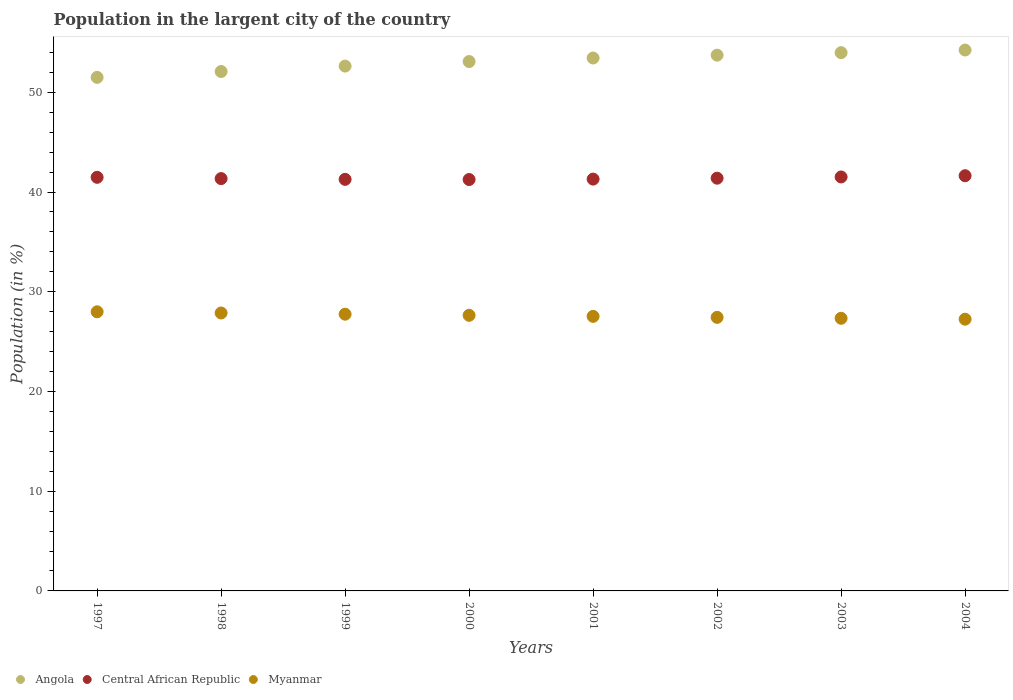Is the number of dotlines equal to the number of legend labels?
Provide a short and direct response. Yes. What is the percentage of population in the largent city in Central African Republic in 2001?
Provide a short and direct response. 41.29. Across all years, what is the maximum percentage of population in the largent city in Central African Republic?
Your answer should be compact. 41.63. Across all years, what is the minimum percentage of population in the largent city in Angola?
Your answer should be very brief. 51.49. In which year was the percentage of population in the largent city in Angola maximum?
Keep it short and to the point. 2004. What is the total percentage of population in the largent city in Central African Republic in the graph?
Your response must be concise. 331.16. What is the difference between the percentage of population in the largent city in Angola in 2000 and that in 2004?
Your answer should be very brief. -1.15. What is the difference between the percentage of population in the largent city in Angola in 2002 and the percentage of population in the largent city in Central African Republic in 2003?
Your answer should be compact. 12.21. What is the average percentage of population in the largent city in Central African Republic per year?
Keep it short and to the point. 41.39. In the year 1999, what is the difference between the percentage of population in the largent city in Myanmar and percentage of population in the largent city in Central African Republic?
Offer a very short reply. -13.52. In how many years, is the percentage of population in the largent city in Angola greater than 34 %?
Offer a terse response. 8. What is the ratio of the percentage of population in the largent city in Central African Republic in 1999 to that in 2000?
Keep it short and to the point. 1. Is the difference between the percentage of population in the largent city in Myanmar in 2000 and 2003 greater than the difference between the percentage of population in the largent city in Central African Republic in 2000 and 2003?
Offer a very short reply. Yes. What is the difference between the highest and the second highest percentage of population in the largent city in Angola?
Provide a succinct answer. 0.26. What is the difference between the highest and the lowest percentage of population in the largent city in Angola?
Your answer should be very brief. 2.74. In how many years, is the percentage of population in the largent city in Myanmar greater than the average percentage of population in the largent city in Myanmar taken over all years?
Provide a succinct answer. 4. Does the percentage of population in the largent city in Angola monotonically increase over the years?
Your response must be concise. Yes. How many years are there in the graph?
Give a very brief answer. 8. What is the difference between two consecutive major ticks on the Y-axis?
Your answer should be compact. 10. Does the graph contain any zero values?
Your answer should be compact. No. How are the legend labels stacked?
Give a very brief answer. Horizontal. What is the title of the graph?
Offer a very short reply. Population in the largent city of the country. What is the label or title of the Y-axis?
Keep it short and to the point. Population (in %). What is the Population (in %) in Angola in 1997?
Provide a short and direct response. 51.49. What is the Population (in %) in Central African Republic in 1997?
Give a very brief answer. 41.47. What is the Population (in %) in Myanmar in 1997?
Make the answer very short. 27.99. What is the Population (in %) in Angola in 1998?
Provide a short and direct response. 52.08. What is the Population (in %) of Central African Republic in 1998?
Offer a very short reply. 41.35. What is the Population (in %) of Myanmar in 1998?
Provide a succinct answer. 27.87. What is the Population (in %) of Angola in 1999?
Ensure brevity in your answer.  52.63. What is the Population (in %) in Central African Republic in 1999?
Offer a very short reply. 41.27. What is the Population (in %) in Myanmar in 1999?
Give a very brief answer. 27.75. What is the Population (in %) of Angola in 2000?
Your answer should be compact. 53.08. What is the Population (in %) of Central African Republic in 2000?
Offer a very short reply. 41.25. What is the Population (in %) of Myanmar in 2000?
Provide a short and direct response. 27.64. What is the Population (in %) in Angola in 2001?
Your response must be concise. 53.44. What is the Population (in %) in Central African Republic in 2001?
Your answer should be compact. 41.29. What is the Population (in %) of Myanmar in 2001?
Your answer should be compact. 27.53. What is the Population (in %) in Angola in 2002?
Ensure brevity in your answer.  53.72. What is the Population (in %) of Central African Republic in 2002?
Offer a terse response. 41.39. What is the Population (in %) of Myanmar in 2002?
Make the answer very short. 27.43. What is the Population (in %) of Angola in 2003?
Provide a short and direct response. 53.97. What is the Population (in %) of Central African Republic in 2003?
Offer a very short reply. 41.51. What is the Population (in %) in Myanmar in 2003?
Make the answer very short. 27.34. What is the Population (in %) of Angola in 2004?
Your response must be concise. 54.24. What is the Population (in %) in Central African Republic in 2004?
Your answer should be compact. 41.63. What is the Population (in %) in Myanmar in 2004?
Offer a terse response. 27.25. Across all years, what is the maximum Population (in %) in Angola?
Give a very brief answer. 54.24. Across all years, what is the maximum Population (in %) in Central African Republic?
Ensure brevity in your answer.  41.63. Across all years, what is the maximum Population (in %) in Myanmar?
Ensure brevity in your answer.  27.99. Across all years, what is the minimum Population (in %) of Angola?
Keep it short and to the point. 51.49. Across all years, what is the minimum Population (in %) of Central African Republic?
Your answer should be compact. 41.25. Across all years, what is the minimum Population (in %) of Myanmar?
Offer a very short reply. 27.25. What is the total Population (in %) in Angola in the graph?
Offer a very short reply. 424.65. What is the total Population (in %) of Central African Republic in the graph?
Give a very brief answer. 331.16. What is the total Population (in %) of Myanmar in the graph?
Offer a very short reply. 220.79. What is the difference between the Population (in %) of Angola in 1997 and that in 1998?
Ensure brevity in your answer.  -0.59. What is the difference between the Population (in %) in Central African Republic in 1997 and that in 1998?
Ensure brevity in your answer.  0.13. What is the difference between the Population (in %) of Myanmar in 1997 and that in 1998?
Your response must be concise. 0.12. What is the difference between the Population (in %) in Angola in 1997 and that in 1999?
Your answer should be very brief. -1.13. What is the difference between the Population (in %) in Central African Republic in 1997 and that in 1999?
Your answer should be very brief. 0.2. What is the difference between the Population (in %) of Myanmar in 1997 and that in 1999?
Your answer should be very brief. 0.24. What is the difference between the Population (in %) in Angola in 1997 and that in 2000?
Your answer should be compact. -1.59. What is the difference between the Population (in %) of Central African Republic in 1997 and that in 2000?
Keep it short and to the point. 0.22. What is the difference between the Population (in %) of Myanmar in 1997 and that in 2000?
Offer a terse response. 0.35. What is the difference between the Population (in %) of Angola in 1997 and that in 2001?
Your response must be concise. -1.94. What is the difference between the Population (in %) in Central African Republic in 1997 and that in 2001?
Provide a succinct answer. 0.18. What is the difference between the Population (in %) in Myanmar in 1997 and that in 2001?
Your answer should be compact. 0.46. What is the difference between the Population (in %) in Angola in 1997 and that in 2002?
Your response must be concise. -2.23. What is the difference between the Population (in %) of Central African Republic in 1997 and that in 2002?
Offer a very short reply. 0.09. What is the difference between the Population (in %) of Myanmar in 1997 and that in 2002?
Make the answer very short. 0.56. What is the difference between the Population (in %) of Angola in 1997 and that in 2003?
Give a very brief answer. -2.48. What is the difference between the Population (in %) of Central African Republic in 1997 and that in 2003?
Provide a short and direct response. -0.04. What is the difference between the Population (in %) in Myanmar in 1997 and that in 2003?
Your answer should be very brief. 0.65. What is the difference between the Population (in %) in Angola in 1997 and that in 2004?
Your answer should be very brief. -2.74. What is the difference between the Population (in %) in Central African Republic in 1997 and that in 2004?
Keep it short and to the point. -0.16. What is the difference between the Population (in %) of Myanmar in 1997 and that in 2004?
Provide a succinct answer. 0.74. What is the difference between the Population (in %) of Angola in 1998 and that in 1999?
Ensure brevity in your answer.  -0.54. What is the difference between the Population (in %) in Central African Republic in 1998 and that in 1999?
Keep it short and to the point. 0.08. What is the difference between the Population (in %) of Myanmar in 1998 and that in 1999?
Make the answer very short. 0.12. What is the difference between the Population (in %) of Angola in 1998 and that in 2000?
Offer a very short reply. -1. What is the difference between the Population (in %) in Central African Republic in 1998 and that in 2000?
Provide a short and direct response. 0.09. What is the difference between the Population (in %) in Myanmar in 1998 and that in 2000?
Keep it short and to the point. 0.23. What is the difference between the Population (in %) of Angola in 1998 and that in 2001?
Ensure brevity in your answer.  -1.35. What is the difference between the Population (in %) of Central African Republic in 1998 and that in 2001?
Ensure brevity in your answer.  0.05. What is the difference between the Population (in %) in Myanmar in 1998 and that in 2001?
Make the answer very short. 0.34. What is the difference between the Population (in %) in Angola in 1998 and that in 2002?
Your answer should be compact. -1.64. What is the difference between the Population (in %) of Central African Republic in 1998 and that in 2002?
Offer a very short reply. -0.04. What is the difference between the Population (in %) of Myanmar in 1998 and that in 2002?
Offer a very short reply. 0.44. What is the difference between the Population (in %) in Angola in 1998 and that in 2003?
Make the answer very short. -1.89. What is the difference between the Population (in %) in Central African Republic in 1998 and that in 2003?
Your answer should be very brief. -0.16. What is the difference between the Population (in %) of Myanmar in 1998 and that in 2003?
Offer a terse response. 0.53. What is the difference between the Population (in %) in Angola in 1998 and that in 2004?
Your response must be concise. -2.15. What is the difference between the Population (in %) in Central African Republic in 1998 and that in 2004?
Keep it short and to the point. -0.29. What is the difference between the Population (in %) of Myanmar in 1998 and that in 2004?
Provide a short and direct response. 0.62. What is the difference between the Population (in %) of Angola in 1999 and that in 2000?
Offer a terse response. -0.46. What is the difference between the Population (in %) in Central African Republic in 1999 and that in 2000?
Your answer should be compact. 0.02. What is the difference between the Population (in %) in Myanmar in 1999 and that in 2000?
Offer a very short reply. 0.11. What is the difference between the Population (in %) of Angola in 1999 and that in 2001?
Offer a very short reply. -0.81. What is the difference between the Population (in %) of Central African Republic in 1999 and that in 2001?
Offer a terse response. -0.02. What is the difference between the Population (in %) in Myanmar in 1999 and that in 2001?
Ensure brevity in your answer.  0.22. What is the difference between the Population (in %) in Angola in 1999 and that in 2002?
Your response must be concise. -1.1. What is the difference between the Population (in %) in Central African Republic in 1999 and that in 2002?
Give a very brief answer. -0.12. What is the difference between the Population (in %) of Myanmar in 1999 and that in 2002?
Your response must be concise. 0.32. What is the difference between the Population (in %) of Angola in 1999 and that in 2003?
Provide a short and direct response. -1.35. What is the difference between the Population (in %) in Central African Republic in 1999 and that in 2003?
Provide a succinct answer. -0.24. What is the difference between the Population (in %) in Myanmar in 1999 and that in 2003?
Provide a succinct answer. 0.41. What is the difference between the Population (in %) in Angola in 1999 and that in 2004?
Offer a very short reply. -1.61. What is the difference between the Population (in %) in Central African Republic in 1999 and that in 2004?
Make the answer very short. -0.36. What is the difference between the Population (in %) of Myanmar in 1999 and that in 2004?
Your answer should be compact. 0.5. What is the difference between the Population (in %) of Angola in 2000 and that in 2001?
Provide a succinct answer. -0.35. What is the difference between the Population (in %) of Central African Republic in 2000 and that in 2001?
Give a very brief answer. -0.04. What is the difference between the Population (in %) of Myanmar in 2000 and that in 2001?
Give a very brief answer. 0.11. What is the difference between the Population (in %) in Angola in 2000 and that in 2002?
Keep it short and to the point. -0.64. What is the difference between the Population (in %) in Central African Republic in 2000 and that in 2002?
Make the answer very short. -0.13. What is the difference between the Population (in %) in Myanmar in 2000 and that in 2002?
Provide a short and direct response. 0.21. What is the difference between the Population (in %) in Angola in 2000 and that in 2003?
Your response must be concise. -0.89. What is the difference between the Population (in %) of Central African Republic in 2000 and that in 2003?
Ensure brevity in your answer.  -0.26. What is the difference between the Population (in %) of Myanmar in 2000 and that in 2003?
Give a very brief answer. 0.3. What is the difference between the Population (in %) in Angola in 2000 and that in 2004?
Offer a very short reply. -1.15. What is the difference between the Population (in %) in Central African Republic in 2000 and that in 2004?
Your response must be concise. -0.38. What is the difference between the Population (in %) in Myanmar in 2000 and that in 2004?
Your response must be concise. 0.39. What is the difference between the Population (in %) of Angola in 2001 and that in 2002?
Your answer should be very brief. -0.29. What is the difference between the Population (in %) of Central African Republic in 2001 and that in 2002?
Make the answer very short. -0.09. What is the difference between the Population (in %) in Myanmar in 2001 and that in 2002?
Offer a very short reply. 0.1. What is the difference between the Population (in %) of Angola in 2001 and that in 2003?
Provide a succinct answer. -0.54. What is the difference between the Population (in %) in Central African Republic in 2001 and that in 2003?
Your response must be concise. -0.22. What is the difference between the Population (in %) of Myanmar in 2001 and that in 2003?
Your response must be concise. 0.19. What is the difference between the Population (in %) of Angola in 2001 and that in 2004?
Give a very brief answer. -0.8. What is the difference between the Population (in %) of Central African Republic in 2001 and that in 2004?
Your answer should be compact. -0.34. What is the difference between the Population (in %) in Myanmar in 2001 and that in 2004?
Ensure brevity in your answer.  0.28. What is the difference between the Population (in %) in Angola in 2002 and that in 2003?
Ensure brevity in your answer.  -0.25. What is the difference between the Population (in %) of Central African Republic in 2002 and that in 2003?
Give a very brief answer. -0.12. What is the difference between the Population (in %) of Myanmar in 2002 and that in 2003?
Your answer should be very brief. 0.09. What is the difference between the Population (in %) in Angola in 2002 and that in 2004?
Make the answer very short. -0.51. What is the difference between the Population (in %) in Central African Republic in 2002 and that in 2004?
Give a very brief answer. -0.25. What is the difference between the Population (in %) of Myanmar in 2002 and that in 2004?
Provide a succinct answer. 0.18. What is the difference between the Population (in %) in Angola in 2003 and that in 2004?
Offer a terse response. -0.26. What is the difference between the Population (in %) in Central African Republic in 2003 and that in 2004?
Offer a terse response. -0.12. What is the difference between the Population (in %) of Myanmar in 2003 and that in 2004?
Offer a terse response. 0.09. What is the difference between the Population (in %) of Angola in 1997 and the Population (in %) of Central African Republic in 1998?
Your answer should be very brief. 10.15. What is the difference between the Population (in %) in Angola in 1997 and the Population (in %) in Myanmar in 1998?
Give a very brief answer. 23.62. What is the difference between the Population (in %) in Central African Republic in 1997 and the Population (in %) in Myanmar in 1998?
Your answer should be compact. 13.6. What is the difference between the Population (in %) in Angola in 1997 and the Population (in %) in Central African Republic in 1999?
Provide a succinct answer. 10.23. What is the difference between the Population (in %) of Angola in 1997 and the Population (in %) of Myanmar in 1999?
Offer a very short reply. 23.75. What is the difference between the Population (in %) of Central African Republic in 1997 and the Population (in %) of Myanmar in 1999?
Your answer should be very brief. 13.73. What is the difference between the Population (in %) of Angola in 1997 and the Population (in %) of Central African Republic in 2000?
Give a very brief answer. 10.24. What is the difference between the Population (in %) in Angola in 1997 and the Population (in %) in Myanmar in 2000?
Provide a succinct answer. 23.86. What is the difference between the Population (in %) in Central African Republic in 1997 and the Population (in %) in Myanmar in 2000?
Your answer should be compact. 13.84. What is the difference between the Population (in %) of Angola in 1997 and the Population (in %) of Central African Republic in 2001?
Your answer should be compact. 10.2. What is the difference between the Population (in %) of Angola in 1997 and the Population (in %) of Myanmar in 2001?
Make the answer very short. 23.96. What is the difference between the Population (in %) of Central African Republic in 1997 and the Population (in %) of Myanmar in 2001?
Ensure brevity in your answer.  13.94. What is the difference between the Population (in %) of Angola in 1997 and the Population (in %) of Central African Republic in 2002?
Your response must be concise. 10.11. What is the difference between the Population (in %) of Angola in 1997 and the Population (in %) of Myanmar in 2002?
Provide a succinct answer. 24.06. What is the difference between the Population (in %) of Central African Republic in 1997 and the Population (in %) of Myanmar in 2002?
Ensure brevity in your answer.  14.04. What is the difference between the Population (in %) of Angola in 1997 and the Population (in %) of Central African Republic in 2003?
Offer a terse response. 9.99. What is the difference between the Population (in %) of Angola in 1997 and the Population (in %) of Myanmar in 2003?
Provide a short and direct response. 24.16. What is the difference between the Population (in %) in Central African Republic in 1997 and the Population (in %) in Myanmar in 2003?
Your answer should be very brief. 14.14. What is the difference between the Population (in %) of Angola in 1997 and the Population (in %) of Central African Republic in 2004?
Offer a terse response. 9.86. What is the difference between the Population (in %) of Angola in 1997 and the Population (in %) of Myanmar in 2004?
Make the answer very short. 24.25. What is the difference between the Population (in %) in Central African Republic in 1997 and the Population (in %) in Myanmar in 2004?
Offer a very short reply. 14.23. What is the difference between the Population (in %) of Angola in 1998 and the Population (in %) of Central African Republic in 1999?
Offer a very short reply. 10.81. What is the difference between the Population (in %) of Angola in 1998 and the Population (in %) of Myanmar in 1999?
Make the answer very short. 24.33. What is the difference between the Population (in %) in Central African Republic in 1998 and the Population (in %) in Myanmar in 1999?
Offer a terse response. 13.6. What is the difference between the Population (in %) in Angola in 1998 and the Population (in %) in Central African Republic in 2000?
Keep it short and to the point. 10.83. What is the difference between the Population (in %) in Angola in 1998 and the Population (in %) in Myanmar in 2000?
Offer a very short reply. 24.45. What is the difference between the Population (in %) in Central African Republic in 1998 and the Population (in %) in Myanmar in 2000?
Keep it short and to the point. 13.71. What is the difference between the Population (in %) of Angola in 1998 and the Population (in %) of Central African Republic in 2001?
Offer a terse response. 10.79. What is the difference between the Population (in %) in Angola in 1998 and the Population (in %) in Myanmar in 2001?
Offer a very short reply. 24.55. What is the difference between the Population (in %) in Central African Republic in 1998 and the Population (in %) in Myanmar in 2001?
Keep it short and to the point. 13.82. What is the difference between the Population (in %) of Angola in 1998 and the Population (in %) of Central African Republic in 2002?
Your response must be concise. 10.7. What is the difference between the Population (in %) of Angola in 1998 and the Population (in %) of Myanmar in 2002?
Provide a short and direct response. 24.65. What is the difference between the Population (in %) of Central African Republic in 1998 and the Population (in %) of Myanmar in 2002?
Keep it short and to the point. 13.91. What is the difference between the Population (in %) of Angola in 1998 and the Population (in %) of Central African Republic in 2003?
Offer a terse response. 10.57. What is the difference between the Population (in %) in Angola in 1998 and the Population (in %) in Myanmar in 2003?
Keep it short and to the point. 24.75. What is the difference between the Population (in %) of Central African Republic in 1998 and the Population (in %) of Myanmar in 2003?
Provide a succinct answer. 14.01. What is the difference between the Population (in %) in Angola in 1998 and the Population (in %) in Central African Republic in 2004?
Keep it short and to the point. 10.45. What is the difference between the Population (in %) of Angola in 1998 and the Population (in %) of Myanmar in 2004?
Your response must be concise. 24.84. What is the difference between the Population (in %) of Central African Republic in 1998 and the Population (in %) of Myanmar in 2004?
Your response must be concise. 14.1. What is the difference between the Population (in %) in Angola in 1999 and the Population (in %) in Central African Republic in 2000?
Provide a succinct answer. 11.37. What is the difference between the Population (in %) in Angola in 1999 and the Population (in %) in Myanmar in 2000?
Your answer should be compact. 24.99. What is the difference between the Population (in %) of Central African Republic in 1999 and the Population (in %) of Myanmar in 2000?
Give a very brief answer. 13.63. What is the difference between the Population (in %) in Angola in 1999 and the Population (in %) in Central African Republic in 2001?
Provide a short and direct response. 11.33. What is the difference between the Population (in %) of Angola in 1999 and the Population (in %) of Myanmar in 2001?
Give a very brief answer. 25.1. What is the difference between the Population (in %) in Central African Republic in 1999 and the Population (in %) in Myanmar in 2001?
Provide a short and direct response. 13.74. What is the difference between the Population (in %) in Angola in 1999 and the Population (in %) in Central African Republic in 2002?
Your answer should be very brief. 11.24. What is the difference between the Population (in %) of Angola in 1999 and the Population (in %) of Myanmar in 2002?
Your answer should be very brief. 25.19. What is the difference between the Population (in %) in Central African Republic in 1999 and the Population (in %) in Myanmar in 2002?
Make the answer very short. 13.84. What is the difference between the Population (in %) of Angola in 1999 and the Population (in %) of Central African Republic in 2003?
Keep it short and to the point. 11.12. What is the difference between the Population (in %) in Angola in 1999 and the Population (in %) in Myanmar in 2003?
Make the answer very short. 25.29. What is the difference between the Population (in %) in Central African Republic in 1999 and the Population (in %) in Myanmar in 2003?
Make the answer very short. 13.93. What is the difference between the Population (in %) in Angola in 1999 and the Population (in %) in Central African Republic in 2004?
Your answer should be very brief. 10.99. What is the difference between the Population (in %) in Angola in 1999 and the Population (in %) in Myanmar in 2004?
Give a very brief answer. 25.38. What is the difference between the Population (in %) of Central African Republic in 1999 and the Population (in %) of Myanmar in 2004?
Your answer should be very brief. 14.02. What is the difference between the Population (in %) in Angola in 2000 and the Population (in %) in Central African Republic in 2001?
Your answer should be compact. 11.79. What is the difference between the Population (in %) of Angola in 2000 and the Population (in %) of Myanmar in 2001?
Your response must be concise. 25.55. What is the difference between the Population (in %) in Central African Republic in 2000 and the Population (in %) in Myanmar in 2001?
Your answer should be very brief. 13.72. What is the difference between the Population (in %) in Angola in 2000 and the Population (in %) in Central African Republic in 2002?
Offer a terse response. 11.7. What is the difference between the Population (in %) in Angola in 2000 and the Population (in %) in Myanmar in 2002?
Make the answer very short. 25.65. What is the difference between the Population (in %) of Central African Republic in 2000 and the Population (in %) of Myanmar in 2002?
Make the answer very short. 13.82. What is the difference between the Population (in %) of Angola in 2000 and the Population (in %) of Central African Republic in 2003?
Make the answer very short. 11.57. What is the difference between the Population (in %) of Angola in 2000 and the Population (in %) of Myanmar in 2003?
Keep it short and to the point. 25.75. What is the difference between the Population (in %) of Central African Republic in 2000 and the Population (in %) of Myanmar in 2003?
Your answer should be very brief. 13.91. What is the difference between the Population (in %) in Angola in 2000 and the Population (in %) in Central African Republic in 2004?
Give a very brief answer. 11.45. What is the difference between the Population (in %) in Angola in 2000 and the Population (in %) in Myanmar in 2004?
Your answer should be compact. 25.83. What is the difference between the Population (in %) in Central African Republic in 2000 and the Population (in %) in Myanmar in 2004?
Keep it short and to the point. 14. What is the difference between the Population (in %) in Angola in 2001 and the Population (in %) in Central African Republic in 2002?
Ensure brevity in your answer.  12.05. What is the difference between the Population (in %) in Angola in 2001 and the Population (in %) in Myanmar in 2002?
Make the answer very short. 26.01. What is the difference between the Population (in %) of Central African Republic in 2001 and the Population (in %) of Myanmar in 2002?
Give a very brief answer. 13.86. What is the difference between the Population (in %) in Angola in 2001 and the Population (in %) in Central African Republic in 2003?
Keep it short and to the point. 11.93. What is the difference between the Population (in %) of Angola in 2001 and the Population (in %) of Myanmar in 2003?
Offer a terse response. 26.1. What is the difference between the Population (in %) of Central African Republic in 2001 and the Population (in %) of Myanmar in 2003?
Make the answer very short. 13.96. What is the difference between the Population (in %) in Angola in 2001 and the Population (in %) in Central African Republic in 2004?
Make the answer very short. 11.8. What is the difference between the Population (in %) in Angola in 2001 and the Population (in %) in Myanmar in 2004?
Provide a succinct answer. 26.19. What is the difference between the Population (in %) in Central African Republic in 2001 and the Population (in %) in Myanmar in 2004?
Your response must be concise. 14.05. What is the difference between the Population (in %) in Angola in 2002 and the Population (in %) in Central African Republic in 2003?
Ensure brevity in your answer.  12.21. What is the difference between the Population (in %) of Angola in 2002 and the Population (in %) of Myanmar in 2003?
Provide a succinct answer. 26.38. What is the difference between the Population (in %) in Central African Republic in 2002 and the Population (in %) in Myanmar in 2003?
Make the answer very short. 14.05. What is the difference between the Population (in %) in Angola in 2002 and the Population (in %) in Central African Republic in 2004?
Provide a succinct answer. 12.09. What is the difference between the Population (in %) of Angola in 2002 and the Population (in %) of Myanmar in 2004?
Ensure brevity in your answer.  26.47. What is the difference between the Population (in %) in Central African Republic in 2002 and the Population (in %) in Myanmar in 2004?
Your response must be concise. 14.14. What is the difference between the Population (in %) in Angola in 2003 and the Population (in %) in Central African Republic in 2004?
Provide a succinct answer. 12.34. What is the difference between the Population (in %) of Angola in 2003 and the Population (in %) of Myanmar in 2004?
Make the answer very short. 26.73. What is the difference between the Population (in %) in Central African Republic in 2003 and the Population (in %) in Myanmar in 2004?
Ensure brevity in your answer.  14.26. What is the average Population (in %) in Angola per year?
Your response must be concise. 53.08. What is the average Population (in %) of Central African Republic per year?
Make the answer very short. 41.4. What is the average Population (in %) of Myanmar per year?
Give a very brief answer. 27.6. In the year 1997, what is the difference between the Population (in %) of Angola and Population (in %) of Central African Republic?
Give a very brief answer. 10.02. In the year 1997, what is the difference between the Population (in %) in Angola and Population (in %) in Myanmar?
Give a very brief answer. 23.51. In the year 1997, what is the difference between the Population (in %) in Central African Republic and Population (in %) in Myanmar?
Give a very brief answer. 13.49. In the year 1998, what is the difference between the Population (in %) in Angola and Population (in %) in Central African Republic?
Your response must be concise. 10.74. In the year 1998, what is the difference between the Population (in %) of Angola and Population (in %) of Myanmar?
Offer a very short reply. 24.21. In the year 1998, what is the difference between the Population (in %) in Central African Republic and Population (in %) in Myanmar?
Your answer should be compact. 13.48. In the year 1999, what is the difference between the Population (in %) of Angola and Population (in %) of Central African Republic?
Your answer should be compact. 11.36. In the year 1999, what is the difference between the Population (in %) of Angola and Population (in %) of Myanmar?
Offer a terse response. 24.88. In the year 1999, what is the difference between the Population (in %) of Central African Republic and Population (in %) of Myanmar?
Give a very brief answer. 13.52. In the year 2000, what is the difference between the Population (in %) of Angola and Population (in %) of Central African Republic?
Offer a very short reply. 11.83. In the year 2000, what is the difference between the Population (in %) in Angola and Population (in %) in Myanmar?
Your response must be concise. 25.45. In the year 2000, what is the difference between the Population (in %) in Central African Republic and Population (in %) in Myanmar?
Provide a succinct answer. 13.62. In the year 2001, what is the difference between the Population (in %) of Angola and Population (in %) of Central African Republic?
Your response must be concise. 12.14. In the year 2001, what is the difference between the Population (in %) in Angola and Population (in %) in Myanmar?
Offer a terse response. 25.91. In the year 2001, what is the difference between the Population (in %) of Central African Republic and Population (in %) of Myanmar?
Your response must be concise. 13.76. In the year 2002, what is the difference between the Population (in %) of Angola and Population (in %) of Central African Republic?
Give a very brief answer. 12.34. In the year 2002, what is the difference between the Population (in %) of Angola and Population (in %) of Myanmar?
Give a very brief answer. 26.29. In the year 2002, what is the difference between the Population (in %) of Central African Republic and Population (in %) of Myanmar?
Offer a terse response. 13.96. In the year 2003, what is the difference between the Population (in %) in Angola and Population (in %) in Central African Republic?
Your answer should be very brief. 12.46. In the year 2003, what is the difference between the Population (in %) in Angola and Population (in %) in Myanmar?
Your answer should be very brief. 26.64. In the year 2003, what is the difference between the Population (in %) of Central African Republic and Population (in %) of Myanmar?
Offer a terse response. 14.17. In the year 2004, what is the difference between the Population (in %) in Angola and Population (in %) in Central African Republic?
Your answer should be compact. 12.6. In the year 2004, what is the difference between the Population (in %) of Angola and Population (in %) of Myanmar?
Provide a succinct answer. 26.99. In the year 2004, what is the difference between the Population (in %) in Central African Republic and Population (in %) in Myanmar?
Give a very brief answer. 14.38. What is the ratio of the Population (in %) in Angola in 1997 to that in 1998?
Offer a terse response. 0.99. What is the ratio of the Population (in %) of Angola in 1997 to that in 1999?
Ensure brevity in your answer.  0.98. What is the ratio of the Population (in %) of Myanmar in 1997 to that in 1999?
Provide a short and direct response. 1.01. What is the ratio of the Population (in %) of Angola in 1997 to that in 2000?
Your answer should be very brief. 0.97. What is the ratio of the Population (in %) in Central African Republic in 1997 to that in 2000?
Make the answer very short. 1.01. What is the ratio of the Population (in %) of Myanmar in 1997 to that in 2000?
Give a very brief answer. 1.01. What is the ratio of the Population (in %) of Angola in 1997 to that in 2001?
Ensure brevity in your answer.  0.96. What is the ratio of the Population (in %) of Central African Republic in 1997 to that in 2001?
Your answer should be compact. 1. What is the ratio of the Population (in %) in Myanmar in 1997 to that in 2001?
Give a very brief answer. 1.02. What is the ratio of the Population (in %) in Angola in 1997 to that in 2002?
Ensure brevity in your answer.  0.96. What is the ratio of the Population (in %) of Central African Republic in 1997 to that in 2002?
Ensure brevity in your answer.  1. What is the ratio of the Population (in %) in Myanmar in 1997 to that in 2002?
Keep it short and to the point. 1.02. What is the ratio of the Population (in %) in Angola in 1997 to that in 2003?
Provide a succinct answer. 0.95. What is the ratio of the Population (in %) of Central African Republic in 1997 to that in 2003?
Ensure brevity in your answer.  1. What is the ratio of the Population (in %) in Myanmar in 1997 to that in 2003?
Make the answer very short. 1.02. What is the ratio of the Population (in %) of Angola in 1997 to that in 2004?
Your answer should be compact. 0.95. What is the ratio of the Population (in %) of Central African Republic in 1997 to that in 2004?
Give a very brief answer. 1. What is the ratio of the Population (in %) of Myanmar in 1997 to that in 2004?
Make the answer very short. 1.03. What is the ratio of the Population (in %) in Central African Republic in 1998 to that in 1999?
Provide a short and direct response. 1. What is the ratio of the Population (in %) of Myanmar in 1998 to that in 1999?
Your answer should be compact. 1. What is the ratio of the Population (in %) of Angola in 1998 to that in 2000?
Ensure brevity in your answer.  0.98. What is the ratio of the Population (in %) in Myanmar in 1998 to that in 2000?
Your response must be concise. 1.01. What is the ratio of the Population (in %) of Angola in 1998 to that in 2001?
Provide a succinct answer. 0.97. What is the ratio of the Population (in %) in Central African Republic in 1998 to that in 2001?
Offer a very short reply. 1. What is the ratio of the Population (in %) of Myanmar in 1998 to that in 2001?
Provide a short and direct response. 1.01. What is the ratio of the Population (in %) of Angola in 1998 to that in 2002?
Provide a short and direct response. 0.97. What is the ratio of the Population (in %) in Angola in 1998 to that in 2003?
Make the answer very short. 0.96. What is the ratio of the Population (in %) of Central African Republic in 1998 to that in 2003?
Offer a very short reply. 1. What is the ratio of the Population (in %) of Myanmar in 1998 to that in 2003?
Keep it short and to the point. 1.02. What is the ratio of the Population (in %) of Angola in 1998 to that in 2004?
Offer a terse response. 0.96. What is the ratio of the Population (in %) in Myanmar in 1998 to that in 2004?
Offer a terse response. 1.02. What is the ratio of the Population (in %) in Central African Republic in 1999 to that in 2001?
Offer a very short reply. 1. What is the ratio of the Population (in %) of Myanmar in 1999 to that in 2001?
Offer a very short reply. 1.01. What is the ratio of the Population (in %) of Angola in 1999 to that in 2002?
Give a very brief answer. 0.98. What is the ratio of the Population (in %) of Central African Republic in 1999 to that in 2002?
Give a very brief answer. 1. What is the ratio of the Population (in %) of Myanmar in 1999 to that in 2002?
Make the answer very short. 1.01. What is the ratio of the Population (in %) in Angola in 1999 to that in 2003?
Provide a succinct answer. 0.97. What is the ratio of the Population (in %) of Central African Republic in 1999 to that in 2003?
Ensure brevity in your answer.  0.99. What is the ratio of the Population (in %) of Myanmar in 1999 to that in 2003?
Your answer should be compact. 1.02. What is the ratio of the Population (in %) of Angola in 1999 to that in 2004?
Your answer should be very brief. 0.97. What is the ratio of the Population (in %) in Central African Republic in 1999 to that in 2004?
Offer a terse response. 0.99. What is the ratio of the Population (in %) of Myanmar in 1999 to that in 2004?
Your response must be concise. 1.02. What is the ratio of the Population (in %) of Myanmar in 2000 to that in 2001?
Provide a short and direct response. 1. What is the ratio of the Population (in %) of Myanmar in 2000 to that in 2002?
Offer a terse response. 1.01. What is the ratio of the Population (in %) in Angola in 2000 to that in 2003?
Provide a succinct answer. 0.98. What is the ratio of the Population (in %) in Myanmar in 2000 to that in 2003?
Provide a short and direct response. 1.01. What is the ratio of the Population (in %) of Angola in 2000 to that in 2004?
Provide a succinct answer. 0.98. What is the ratio of the Population (in %) in Central African Republic in 2000 to that in 2004?
Give a very brief answer. 0.99. What is the ratio of the Population (in %) in Myanmar in 2000 to that in 2004?
Provide a short and direct response. 1.01. What is the ratio of the Population (in %) in Central African Republic in 2001 to that in 2002?
Your answer should be compact. 1. What is the ratio of the Population (in %) in Angola in 2001 to that in 2003?
Offer a terse response. 0.99. What is the ratio of the Population (in %) of Central African Republic in 2001 to that in 2003?
Ensure brevity in your answer.  0.99. What is the ratio of the Population (in %) in Myanmar in 2001 to that in 2003?
Offer a very short reply. 1.01. What is the ratio of the Population (in %) of Myanmar in 2001 to that in 2004?
Your answer should be very brief. 1.01. What is the ratio of the Population (in %) in Angola in 2002 to that in 2003?
Your answer should be compact. 1. What is the ratio of the Population (in %) in Central African Republic in 2002 to that in 2003?
Offer a terse response. 1. What is the ratio of the Population (in %) in Myanmar in 2002 to that in 2003?
Keep it short and to the point. 1. What is the ratio of the Population (in %) of Angola in 2002 to that in 2004?
Keep it short and to the point. 0.99. What is the ratio of the Population (in %) of Myanmar in 2002 to that in 2004?
Your response must be concise. 1.01. What is the ratio of the Population (in %) in Central African Republic in 2003 to that in 2004?
Your answer should be compact. 1. What is the ratio of the Population (in %) of Myanmar in 2003 to that in 2004?
Ensure brevity in your answer.  1. What is the difference between the highest and the second highest Population (in %) of Angola?
Give a very brief answer. 0.26. What is the difference between the highest and the second highest Population (in %) of Central African Republic?
Give a very brief answer. 0.12. What is the difference between the highest and the second highest Population (in %) of Myanmar?
Provide a short and direct response. 0.12. What is the difference between the highest and the lowest Population (in %) of Angola?
Your answer should be compact. 2.74. What is the difference between the highest and the lowest Population (in %) of Central African Republic?
Offer a very short reply. 0.38. What is the difference between the highest and the lowest Population (in %) in Myanmar?
Provide a succinct answer. 0.74. 